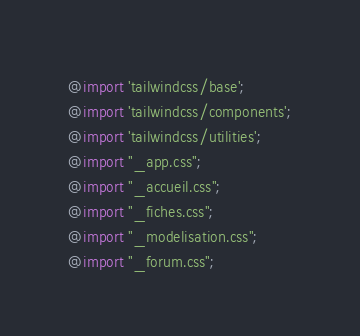<code> <loc_0><loc_0><loc_500><loc_500><_CSS_>@import 'tailwindcss/base';
@import 'tailwindcss/components';
@import 'tailwindcss/utilities';
@import "_app.css";
@import "_accueil.css";
@import "_fiches.css";
@import "_modelisation.css";
@import "_forum.css";
</code> 